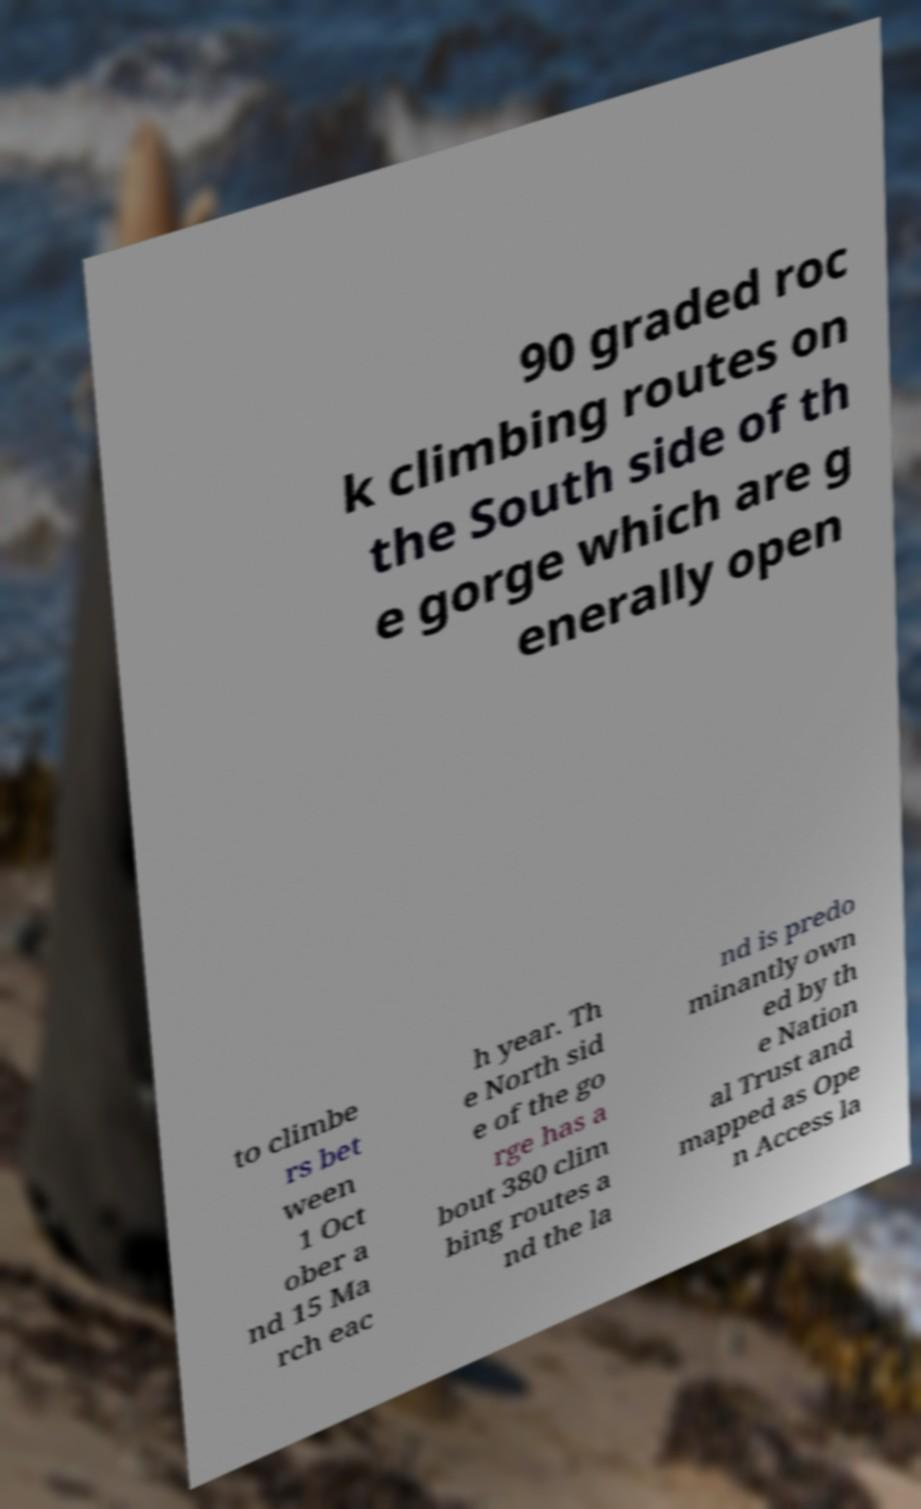Can you read and provide the text displayed in the image?This photo seems to have some interesting text. Can you extract and type it out for me? 90 graded roc k climbing routes on the South side of th e gorge which are g enerally open to climbe rs bet ween 1 Oct ober a nd 15 Ma rch eac h year. Th e North sid e of the go rge has a bout 380 clim bing routes a nd the la nd is predo minantly own ed by th e Nation al Trust and mapped as Ope n Access la 